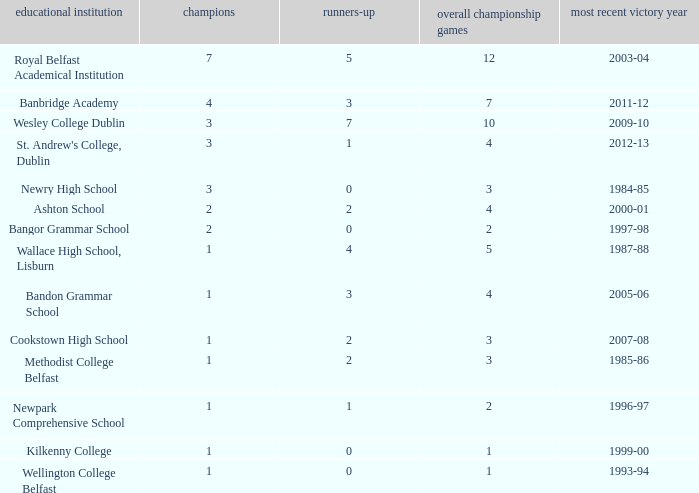What is the name of the school where the year of last win is 1985-86? Methodist College Belfast. 